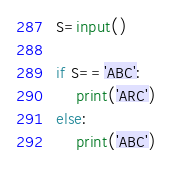<code> <loc_0><loc_0><loc_500><loc_500><_Python_>S=input()

if S=='ABC':
    print('ARC')
else:
    print('ABC')</code> 